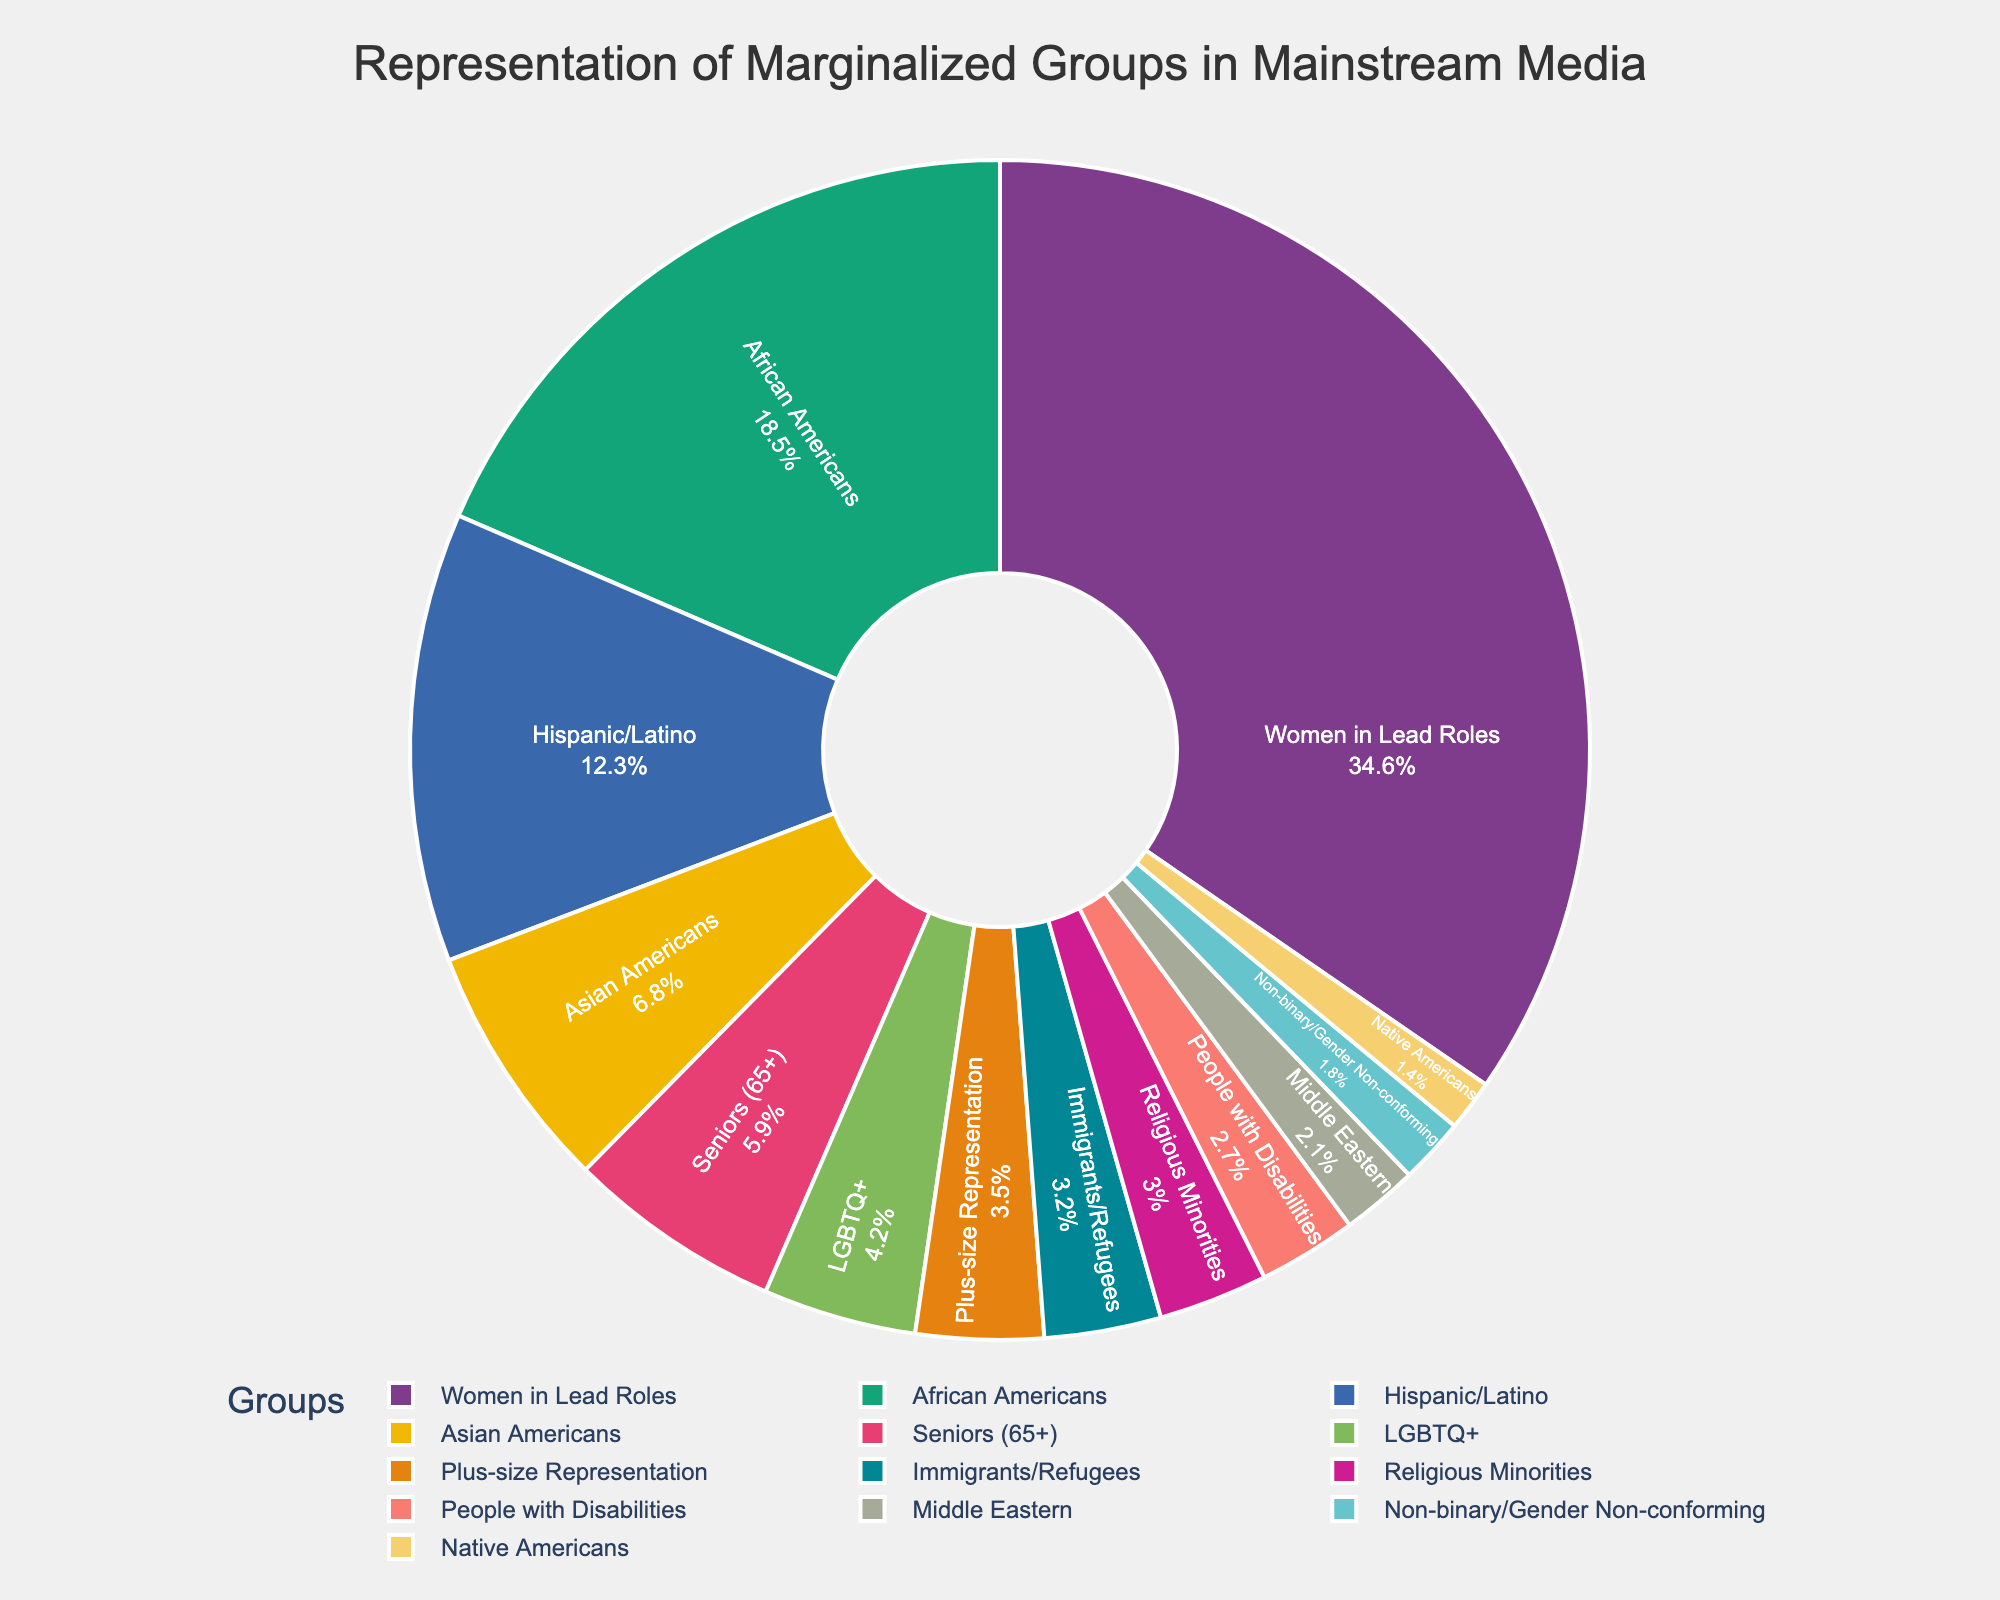Which marginalized group has the largest representation in mainstream media? By examining the slices of the pie chart, we can see that the 'Women in Lead Roles' category has the largest slice of the pie, indicating it has the highest percentage at 34.6%.
Answer: Women in Lead Roles Which marginalized group has the smallest representation compared to others? Observing the pie chart, the smallest slice is attributed to the 'Native Americans' category, which indicates a percentage of 1.4%.
Answer: Native Americans How does the representation of African Americans compare to that of Hispanic/Latino? By looking at the chart, the 'African Americans' slice is larger than the 'Hispanic/Latino' slice. Specifically, African Americans are represented at 18.5% while Hispanic/Latino are at 12.3%.
Answer: African Americans have higher representation What is the combined representation percentage of LGBTQ+ and Non-binary/Gender Non-conforming groups? From the chart, the LGBTQ+ group is represented at 4.2% and the Non-binary/Gender Non-conforming group at 1.8%. Adding these percentages gives a combined representation of 6.0%.
Answer: 6.0% Which group has the least difference in representation percentage compared to Plus-size representation? Plus-size Representation is 3.5%, and comparing all categories from the pie chart, Religious Minorities at 3.0% is the closest in percentage. The difference is 0.5%.
Answer: Religious Minorities What is the total representation percentage of groups that each have less than 5% representation? Groups with less than 5% representation are LGBTQ+ (4.2%), People with Disabilities (2.7%), Native Americans (1.4%), Middle Eastern (2.1%), Non-binary/Gender Non-conforming (1.8%), Seniors (65+) (5.9% not included), Immigrants/Refugees (3.2%), Plus-size Representation (3.5%), and Religious Minorities (3.0%). Adding these gives 4.2% + 2.7% + 1.4% + 2.1% + 1.8% + 3.2% + 3.5% + 3.0% = 21.9%.
Answer: 21.9% How much more represented are African Americans than Asian Americans in mainstream media? The chart shows African Americans at 18.5% and Asian Americans at 6.8%. The difference is 18.5% - 6.8% = 11.7%.
Answer: 11.7% Compared to the representation of African Americans, is the representation of Women in Lead Roles greater or less, and by what percentage? Women in Lead Roles are represented at 34.6% and African Americans at 18.5%. The representation of Women in Lead Roles is greater by 34.6% - 18.5% = 16.1%.
Answer: Greater by 16.1% Which groups have a representation percentage closest to the average representation of all groups combined? To find the average, sum all the percentages and divide by the number of groups. Summing the values: 18.5 + 12.3 + 6.8 + 4.2 + 2.7 + 1.4 + 2.1 + 34.6 + 1.8 + 5.9 + 3.2 + 3.5 + 3.0 = 100%, this means the average representation is 100%/13 groups ≈ 7.69%. Middle Eastern (2.1%) and Non-binary/Gender Non-conforming (1.8%) are not close whereas Seniors (65+) at 5.9% and Asian Americans at 6.8% are closest to the average.
Answer: Seniors (65+) and Asian Americans 